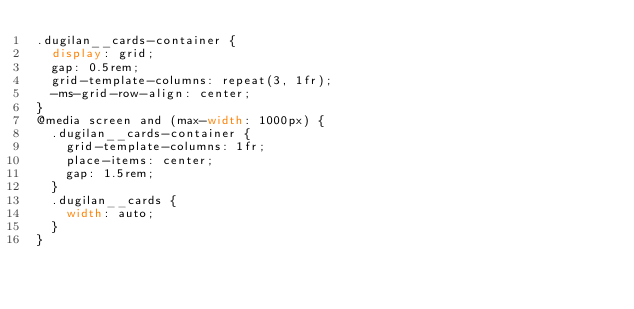<code> <loc_0><loc_0><loc_500><loc_500><_CSS_>.dugilan__cards-container {
  display: grid;
  gap: 0.5rem;
  grid-template-columns: repeat(3, 1fr);
  -ms-grid-row-align: center;
}
@media screen and (max-width: 1000px) {
  .dugilan__cards-container {
    grid-template-columns: 1fr;
    place-items: center;
    gap: 1.5rem;
  }
  .dugilan__cards {
    width: auto;
  }
}
</code> 